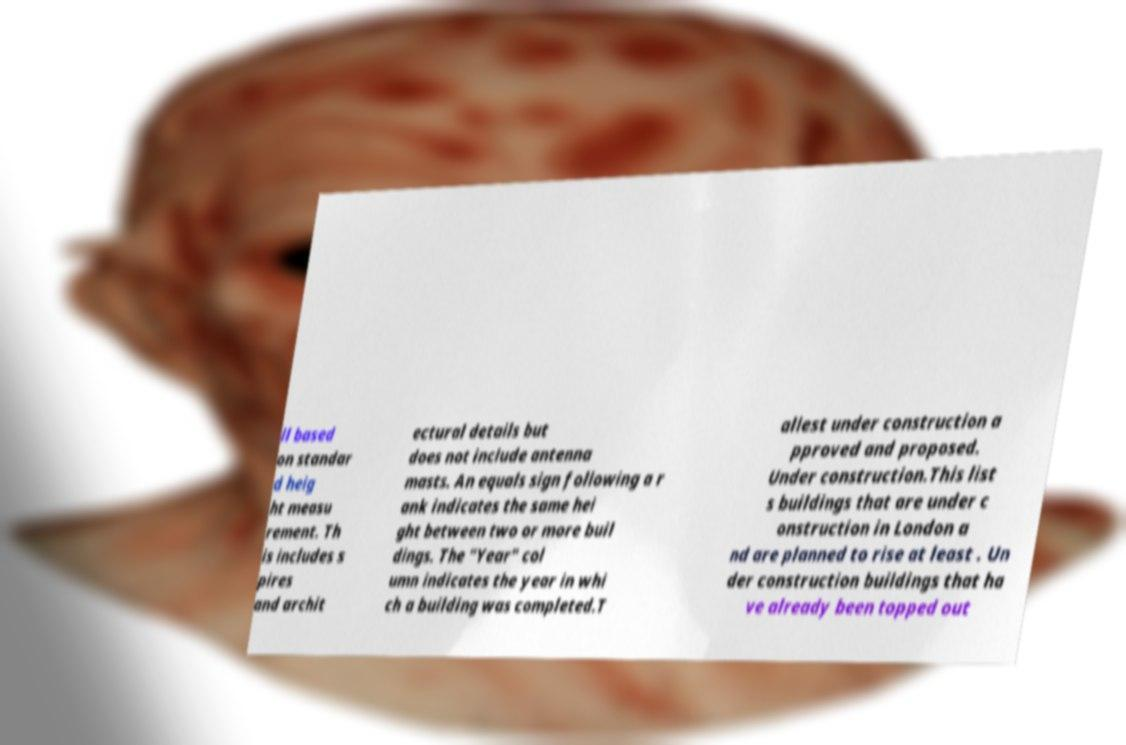What messages or text are displayed in this image? I need them in a readable, typed format. ll based on standar d heig ht measu rement. Th is includes s pires and archit ectural details but does not include antenna masts. An equals sign following a r ank indicates the same hei ght between two or more buil dings. The "Year" col umn indicates the year in whi ch a building was completed.T allest under construction a pproved and proposed. Under construction.This list s buildings that are under c onstruction in London a nd are planned to rise at least . Un der construction buildings that ha ve already been topped out 